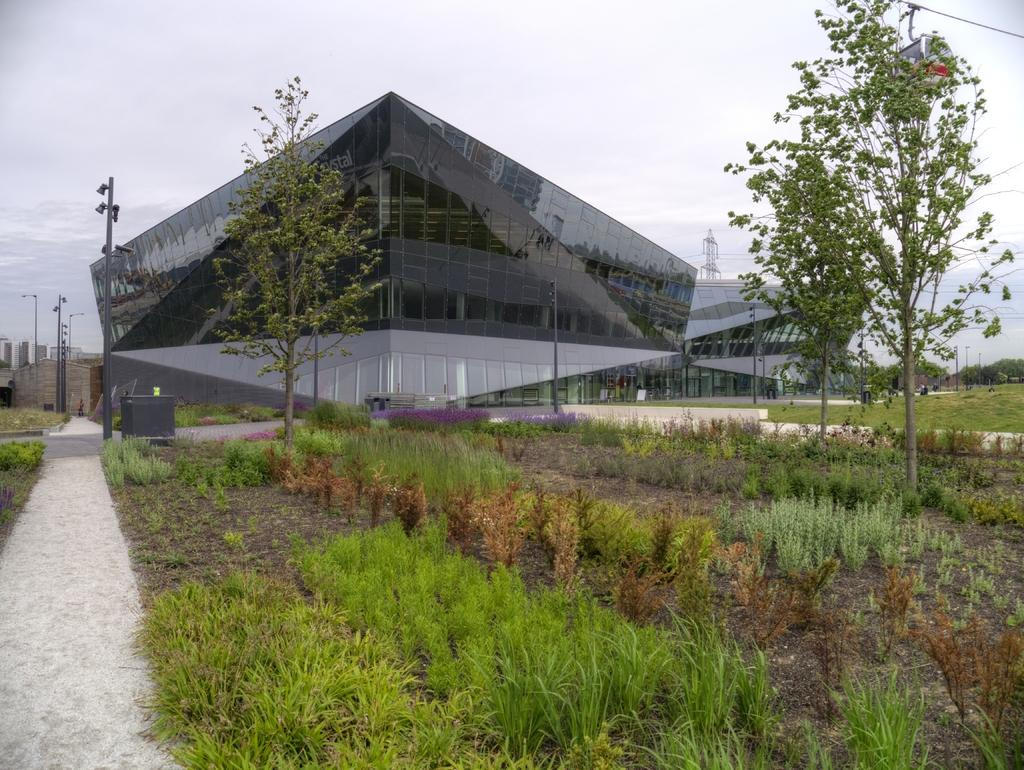What type of vegetation is present in the image? There are plants and trees in the image. What structures can be seen in the background of the image? There are poles and at least one building in the background of the image. What tall structure is visible in the image? There is a tower in the image. What part of the natural environment is visible in the image? The sky is visible in the background of the image. What type of shirt is hanging from the tower in the image? There is no shirt present in the image, and the tower does not have any clothing items hanging from it. 